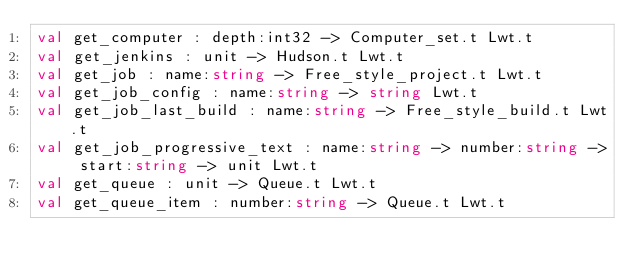Convert code to text. <code><loc_0><loc_0><loc_500><loc_500><_OCaml_>val get_computer : depth:int32 -> Computer_set.t Lwt.t
val get_jenkins : unit -> Hudson.t Lwt.t
val get_job : name:string -> Free_style_project.t Lwt.t
val get_job_config : name:string -> string Lwt.t
val get_job_last_build : name:string -> Free_style_build.t Lwt.t
val get_job_progressive_text : name:string -> number:string -> start:string -> unit Lwt.t
val get_queue : unit -> Queue.t Lwt.t
val get_queue_item : number:string -> Queue.t Lwt.t</code> 